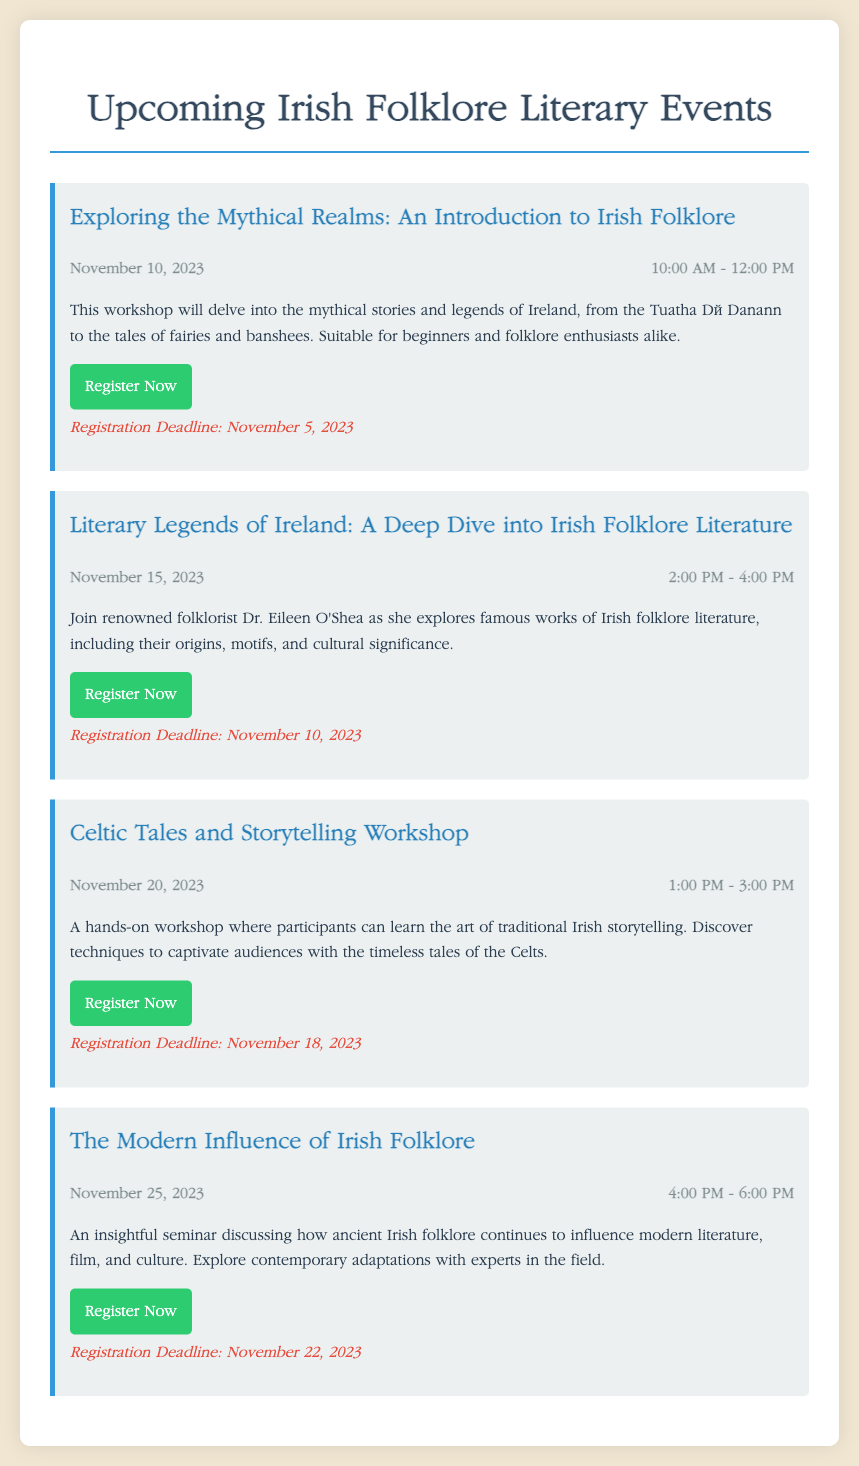What is the title of the first event? The title of the first event is listed at the top of the first event section in the document.
Answer: Exploring the Mythical Realms: An Introduction to Irish Folklore When is the workshop on Celtic Tales scheduled? The date is provided in the event details of the Celtic Tales section within the document.
Answer: November 20, 2023 Who is the speaker for the "Literary Legends of Ireland" event? The speaker's name is mentioned in the description of the Literary Legends event.
Answer: Dr. Eileen O'Shea What time does the last event start? The event time is included in the details of the last event in the document.
Answer: 4:00 PM What is the registration deadline for the workshop on storytelling? The registration deadline can be found at the bottom of the storytelling workshop section.
Answer: November 18, 2023 How long is the "Exploring the Mythical Realms" workshop? The duration of the workshop is inferred from the event time provided in the first event details.
Answer: 2 hours What is the main topic of the "Modern Influence of Irish Folklore" seminar? The main topic is mentioned in the description of the seminar regarding its content.
Answer: Influence of ancient Irish folklore on modern literature, film, and culture How many events are listed in the document? The number of events can be counted from the distinct event sections present in the document.
Answer: 4 What is the URL for registration of the "Celtic Tales and Storytelling Workshop"? The registration link is included in the event details of the specific workshop.
Answer: http://irelandfolkloreevents.com/celtic-tales 